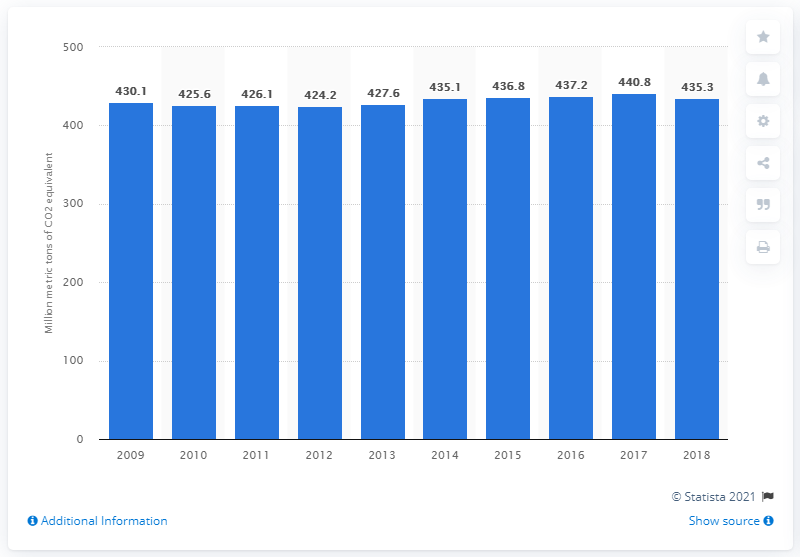Highlight a few significant elements in this photo. Since 2009, greenhouse gas emissions from agriculture have slightly increased. In 2018, the agricultural sector released 435.3 million metric tons of CO2 equivalent of greenhouse gas emissions, which is a significant contribution to global greenhouse gas emissions. 